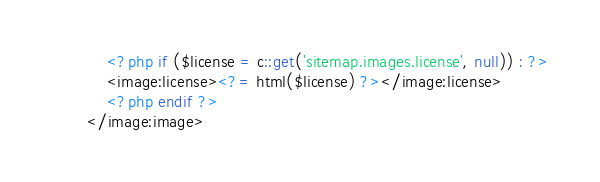Convert code to text. <code><loc_0><loc_0><loc_500><loc_500><_PHP_>
	<?php if ($license = c::get('sitemap.images.license', null)) : ?>
	<image:license><?= html($license) ?></image:license>
	<?php endif ?>
</image:image>
</code> 